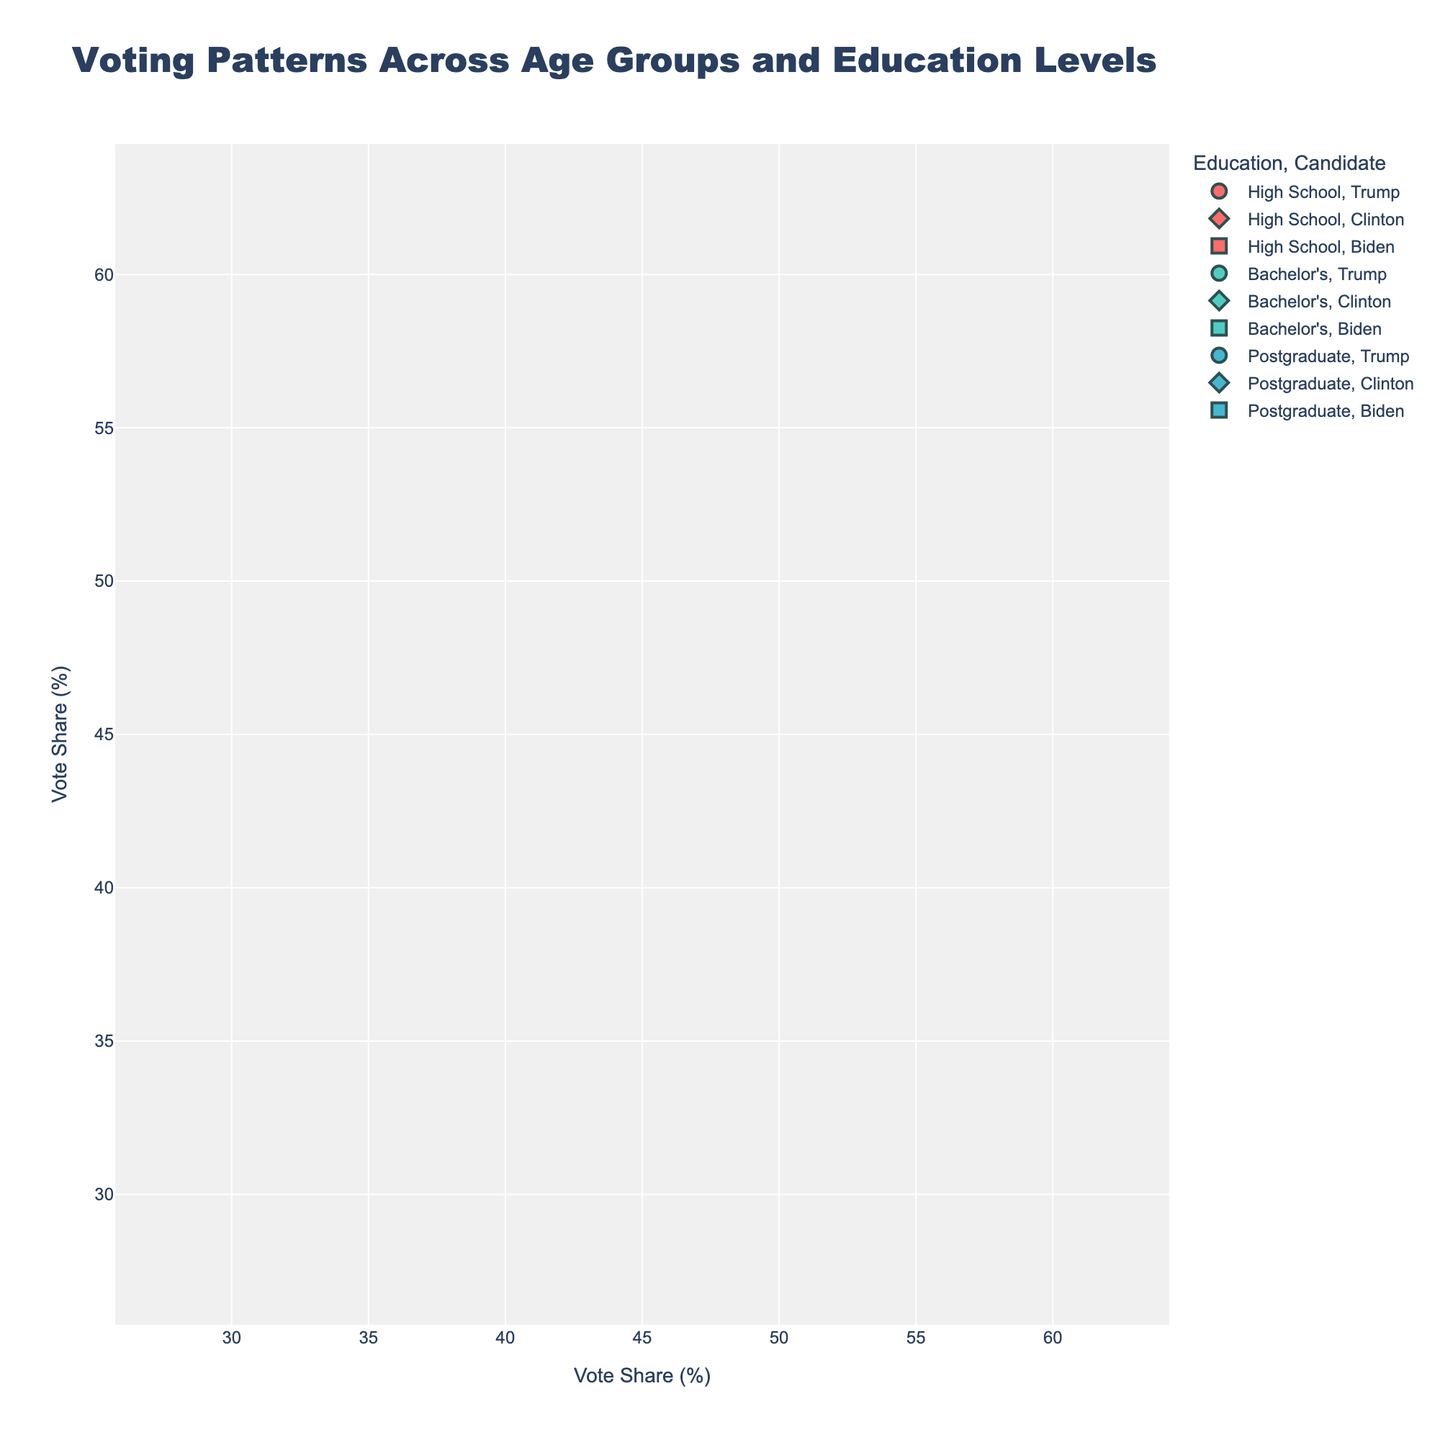What is the title of the figure? The title is usually found at the top of the figure. In this case, it reads "Market Demand for Organic Sports Nutrition Products by Age Group."
Answer: Market Demand for Organic Sports Nutrition Products by Age Group What is the market demand for the 25-34 age group in the year 2014? Look at the subplot titled "25-34" and find the point on the line corresponding to the year 2014. The y-axis will give the market demand value.
Answer: 25 Which age group had the highest market demand in 2022? Look at the year 2022 across all subplots and compare the y-values. The subplot with the highest point is the age group with the highest market demand.
Answer: 35-44 How did the market demand for the 18-24 age group change between 2010 and 2020? Refer to the subplot titled "18-24" and compare the values at the years 2010 and 2020. Calculate the difference in y-axis values.
Answer: It increased from 12 to 41 By how much did the market demand for the 55+ age group increase from 2016 to 2022? Look at the subplot titled "55+" and find the points for the years 2016 and 2022. Subtract the market demand in 2016 from that in 2022.
Answer: 18 (35 - 17) Which age group showed the most consistent increase in market demand over the years? Compare the slope of the lines in all subplots. The age group with the most uniform upward trend without significant fluctuations indicates the most consistent increase.
Answer: 35-44 At which year did the 45-54 age group see a significant spike in market demand? Examine the subplot titled "45-54" to identify any sudden increase in the values along the x-axis. The significant spike is noticeable between two consecutive data points.
Answer: 2018 What is the overall trend in market demand for organic sports nutrition products across all age groups from 2010 to 2022? Look at the direction of all the lines in the subplots from 2010 to 2022, generally trending upwards across all age groups.
Answer: Upward trend How does the market demand for the 35-44 age group in 2020 compare to that of the 18-24 age group in 2022? Find the 2020 value in the 35-44 subplot and the 2022 value in the 18-24 subplot and compare them.
Answer: 35-44 in 2020 (52) is higher than 18-24 in 2022 (50) What's the average market demand for the 25-34 age group over the entire period shown? Add the market demand values for the 25-34 age group from all the corresponding years and divide by the total number of years.
Answer: (15 + 19 + 25 + 32 + 40 + 49 + 59) / 7 = 34.14 